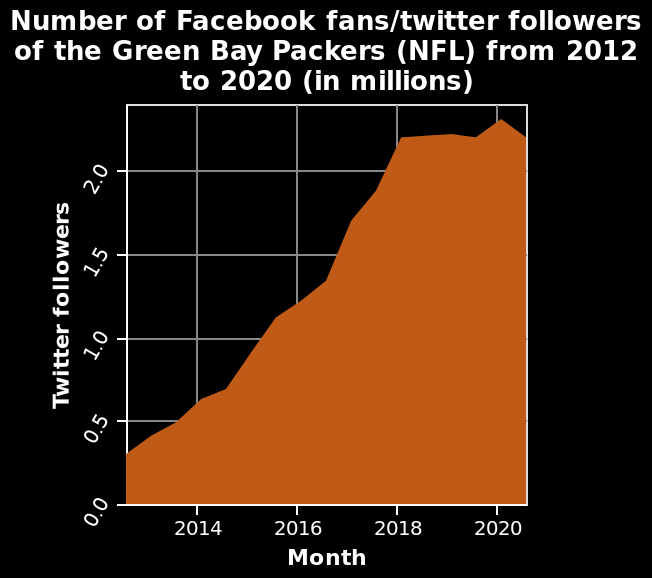<image>
Is the scale used for Twitter followers linear or logarithmic? The scale used for Twitter followers is linear. Describe the following image in detail Number of Facebook fans/twitter followers of the Green Bay Packers (NFL) from 2012 to 2020 (in millions) is a area plot. Twitter followers is shown using a linear scale with a minimum of 0.0 and a maximum of 2.0 on the y-axis. Month is shown with a linear scale with a minimum of 2014 and a maximum of 2020 on the x-axis. What is the range of values on the y-axis for the Twitter followers in the area plot? The range of values on the y-axis for the Twitter followers is from 0.0 to 2.0. What period of time did the Green Bay Packer's followers show a consistent increase? The Green Bay Packer's followers showed a consistent increase from 2012 to mid 2016. 